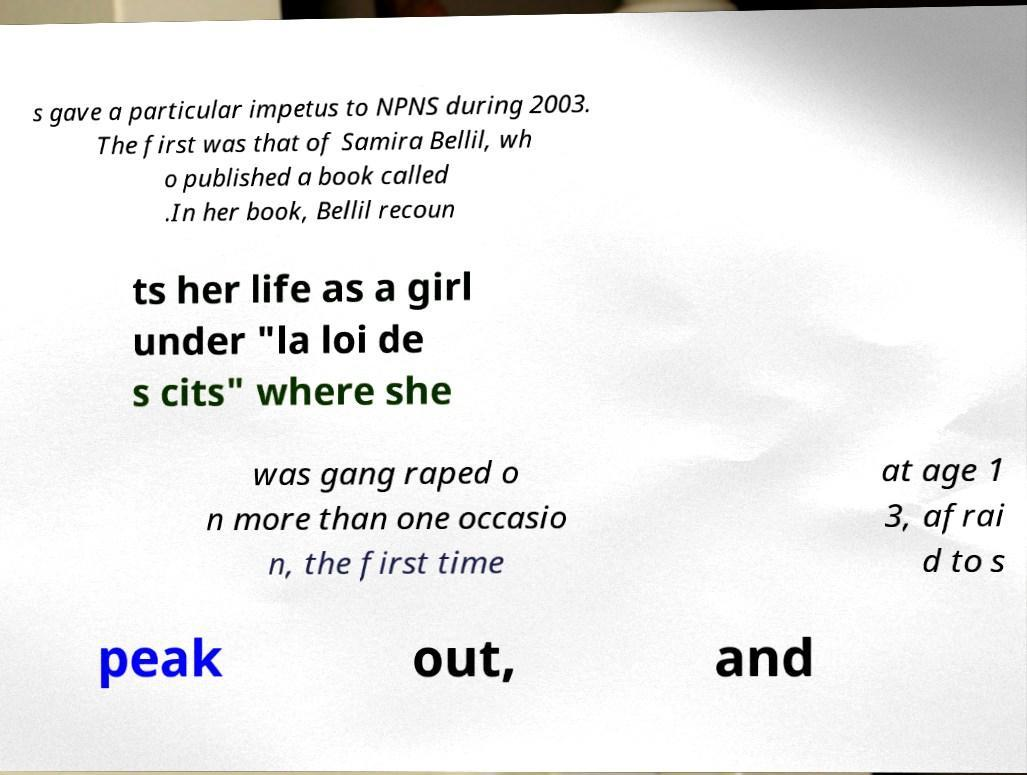Please identify and transcribe the text found in this image. s gave a particular impetus to NPNS during 2003. The first was that of Samira Bellil, wh o published a book called .In her book, Bellil recoun ts her life as a girl under "la loi de s cits" where she was gang raped o n more than one occasio n, the first time at age 1 3, afrai d to s peak out, and 